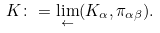Convert formula to latex. <formula><loc_0><loc_0><loc_500><loc_500>K \colon = \lim _ { \leftarrow } ( K _ { \alpha } , \pi _ { \alpha \beta } ) .</formula> 